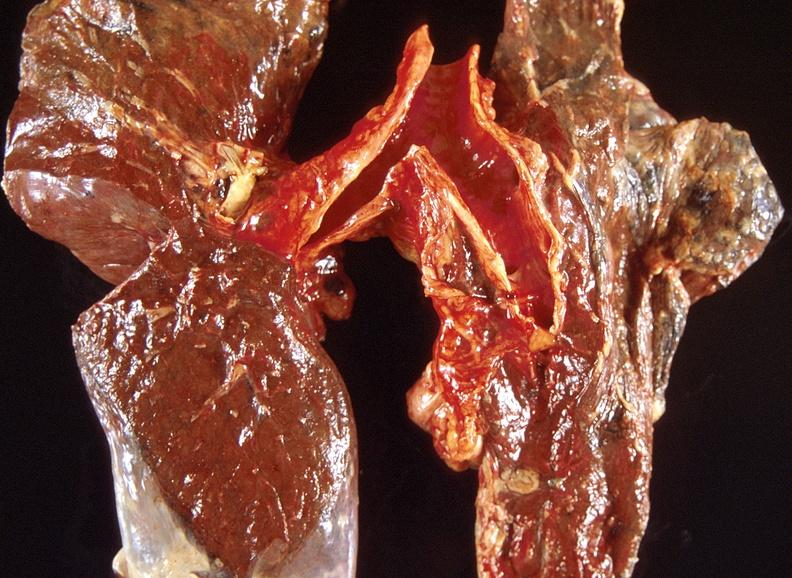does maxillary sinus show lung carcinoma?
Answer the question using a single word or phrase. No 